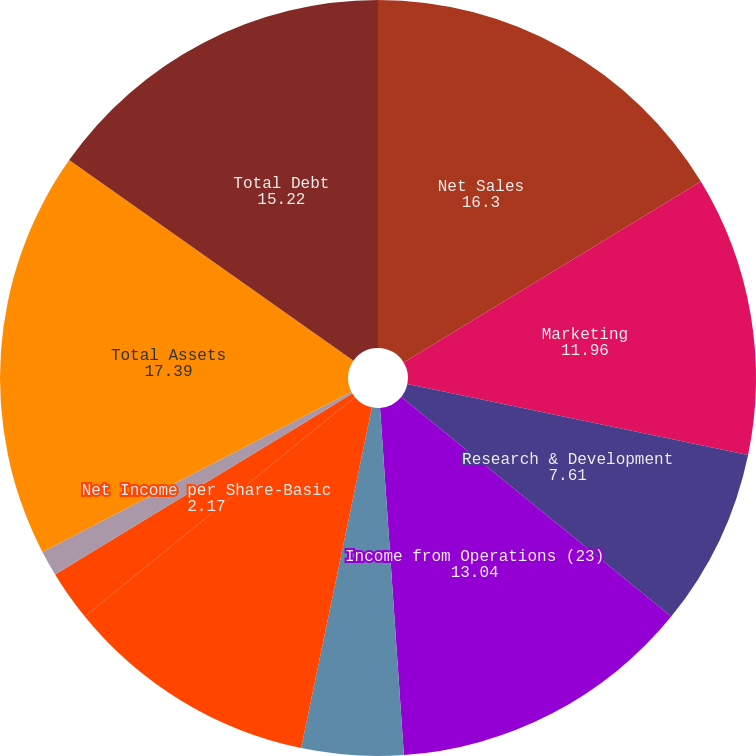<chart> <loc_0><loc_0><loc_500><loc_500><pie_chart><fcel>Net Sales<fcel>Marketing<fcel>Research & Development<fcel>Income from Operations (23)<fcel>of Sales<fcel>Net Income attributable to<fcel>Net Income per Share-Basic<fcel>Net Income per Share-Diluted<fcel>Total Assets<fcel>Total Debt<nl><fcel>16.3%<fcel>11.96%<fcel>7.61%<fcel>13.04%<fcel>4.35%<fcel>10.87%<fcel>2.17%<fcel>1.09%<fcel>17.39%<fcel>15.22%<nl></chart> 